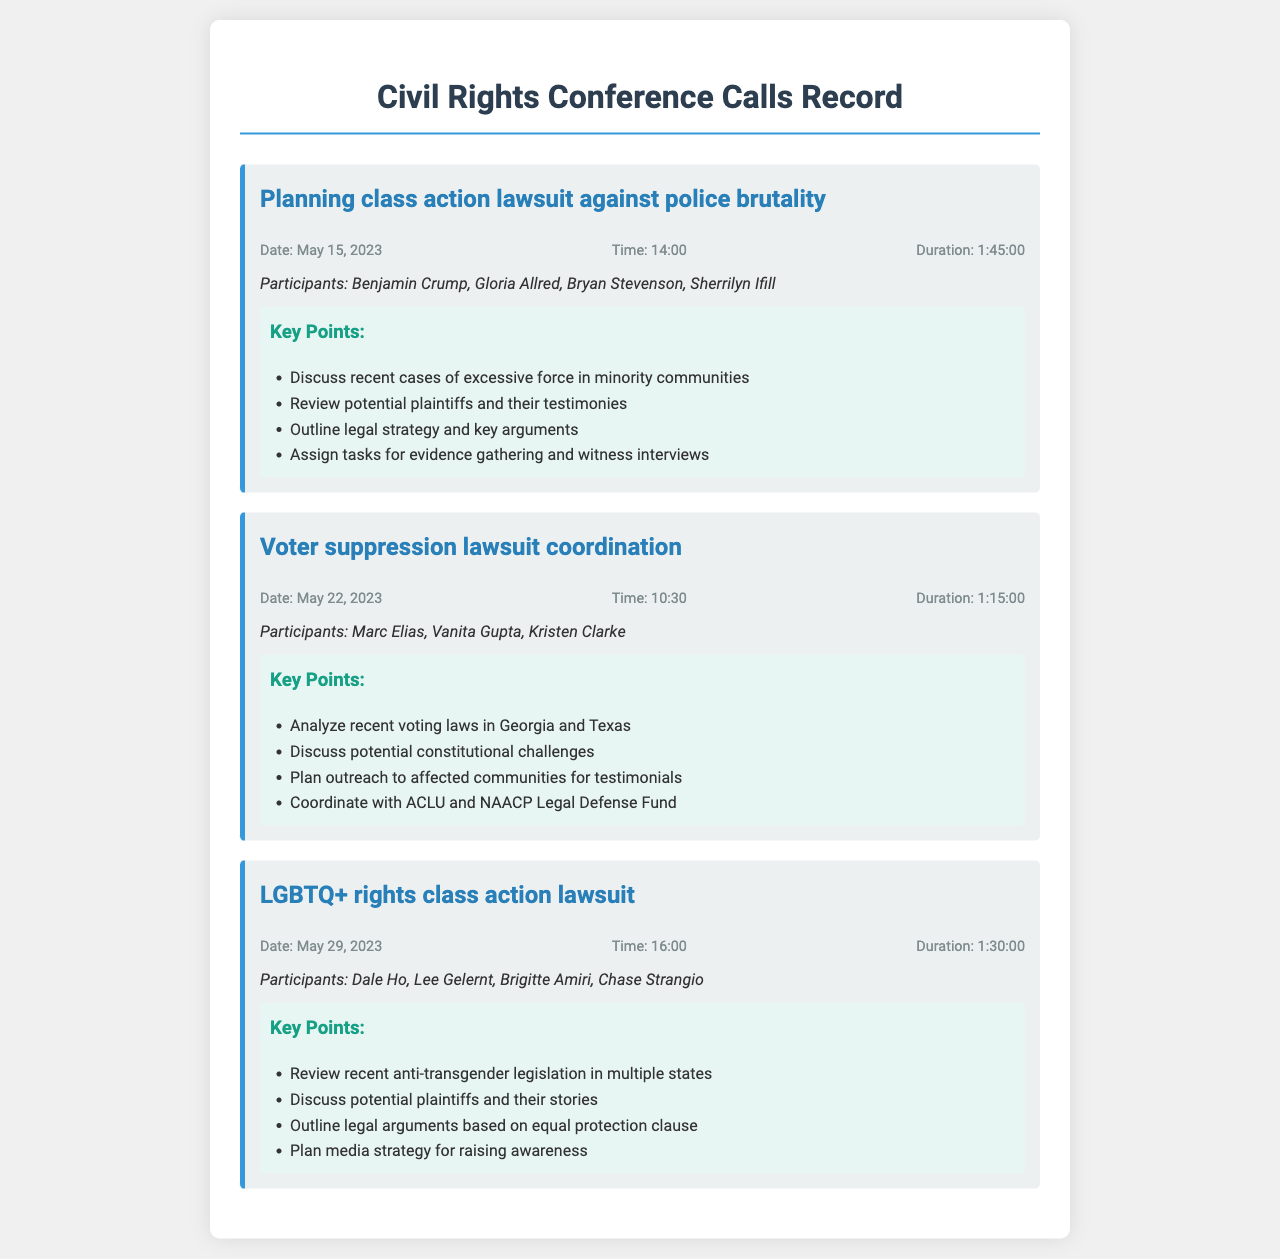What was the date of the call regarding police brutality? The date can be found in the call record for the police brutality lawsuit, which states May 15, 2023.
Answer: May 15, 2023 How long did the call about voter suppression last? The duration in the call record for the voter suppression lawsuit indicates it lasted for 1:15:00.
Answer: 1:15:00 Who were the participants in the LGBTQ+ rights call? The names of the participants are listed in the LGBTQ+ rights call record: Dale Ho, Lee Gelernt, Brigitte Amiri, Chase Strangio.
Answer: Dale Ho, Lee Gelernt, Brigitte Amiri, Chase Strangio What was one of the key points discussed in the police brutality call? The key points in the police brutality call include discussing recent cases of excessive force in minority communities.
Answer: Discuss recent cases of excessive force in minority communities Which organization was coordinated with during the voter suppression lawsuit planning? The call record for the voter suppression lawsuit indicates coordination with the ACLU and NAACP Legal Defense Fund.
Answer: ACLU and NAACP Legal Defense Fund What time did the LGBTQ+ rights call start? The call record specifies that the time for the LGBTQ+ rights call was 16:00.
Answer: 16:00 Who was one of the participants in the voter suppression call? The document lists the participants, including Marc Elias, who was part of the voter suppression call.
Answer: Marc Elias What legal concept was outlined as a basis for the LGBTQ+ rights lawsuit? The key points state that legal arguments were outlined based on the equal protection clause.
Answer: Equal protection clause 